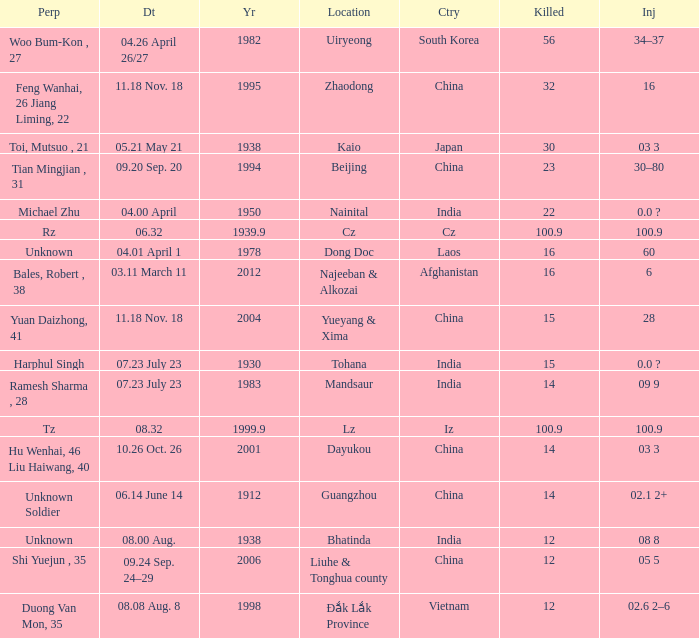What is the average Year, when Date is "04.01 April 1"? 1978.0. 